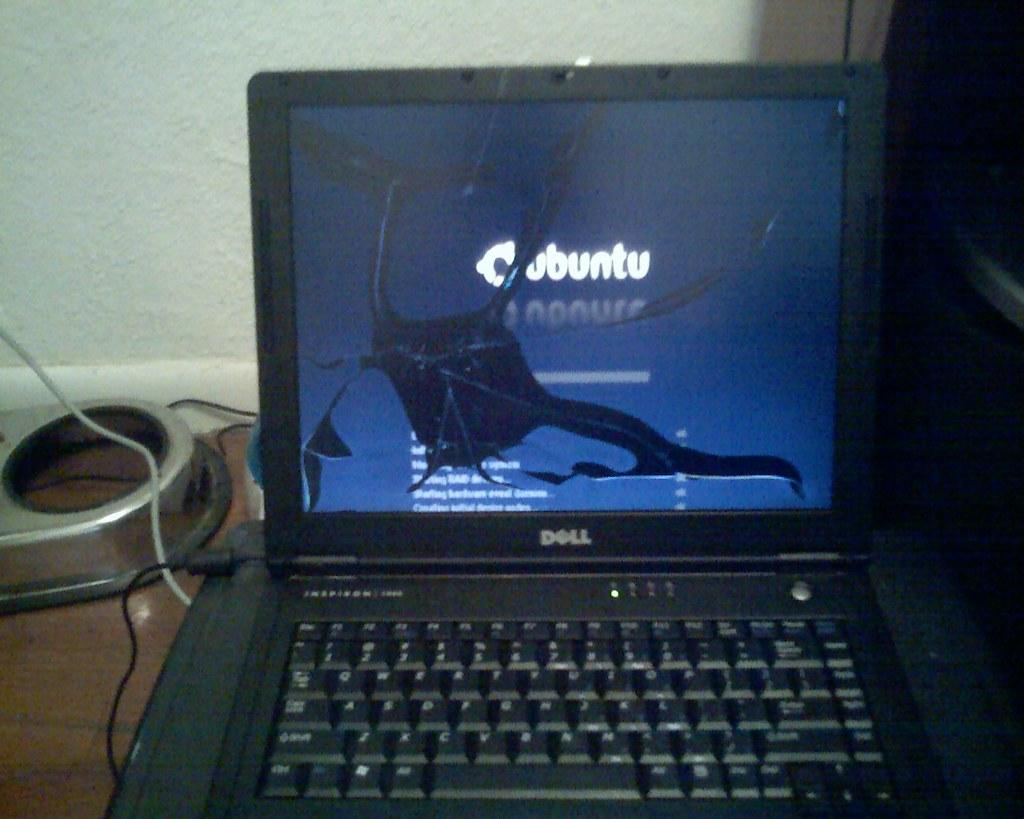Provide a one-sentence caption for the provided image. A dell computer screen is cracked and bleeding black. 